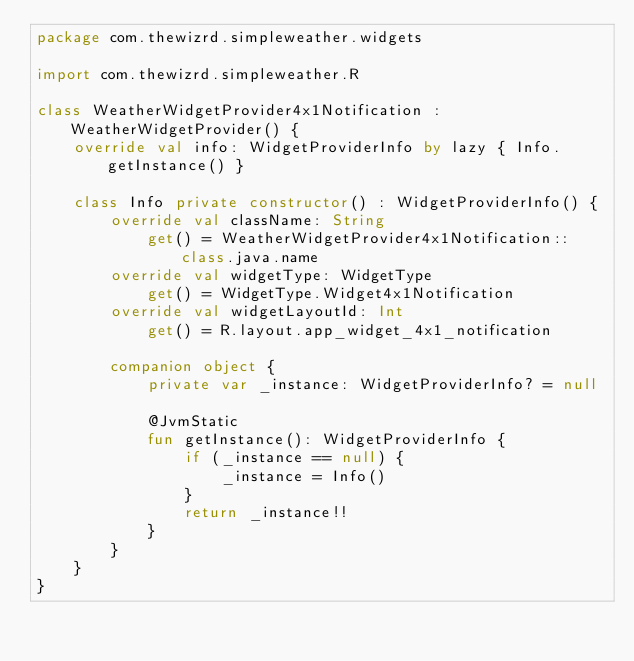<code> <loc_0><loc_0><loc_500><loc_500><_Kotlin_>package com.thewizrd.simpleweather.widgets

import com.thewizrd.simpleweather.R

class WeatherWidgetProvider4x1Notification : WeatherWidgetProvider() {
    override val info: WidgetProviderInfo by lazy { Info.getInstance() }

    class Info private constructor() : WidgetProviderInfo() {
        override val className: String
            get() = WeatherWidgetProvider4x1Notification::class.java.name
        override val widgetType: WidgetType
            get() = WidgetType.Widget4x1Notification
        override val widgetLayoutId: Int
            get() = R.layout.app_widget_4x1_notification

        companion object {
            private var _instance: WidgetProviderInfo? = null

            @JvmStatic
            fun getInstance(): WidgetProviderInfo {
                if (_instance == null) {
                    _instance = Info()
                }
                return _instance!!
            }
        }
    }
}</code> 